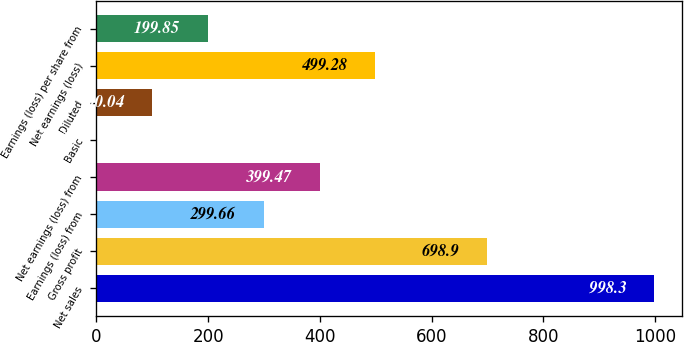<chart> <loc_0><loc_0><loc_500><loc_500><bar_chart><fcel>Net sales<fcel>Gross profit<fcel>Earnings (loss) from<fcel>Net earnings (loss) from<fcel>Basic<fcel>Diluted<fcel>Net earnings (loss)<fcel>Earnings (loss) per share from<nl><fcel>998.3<fcel>698.9<fcel>299.66<fcel>399.47<fcel>0.23<fcel>100.04<fcel>499.28<fcel>199.85<nl></chart> 